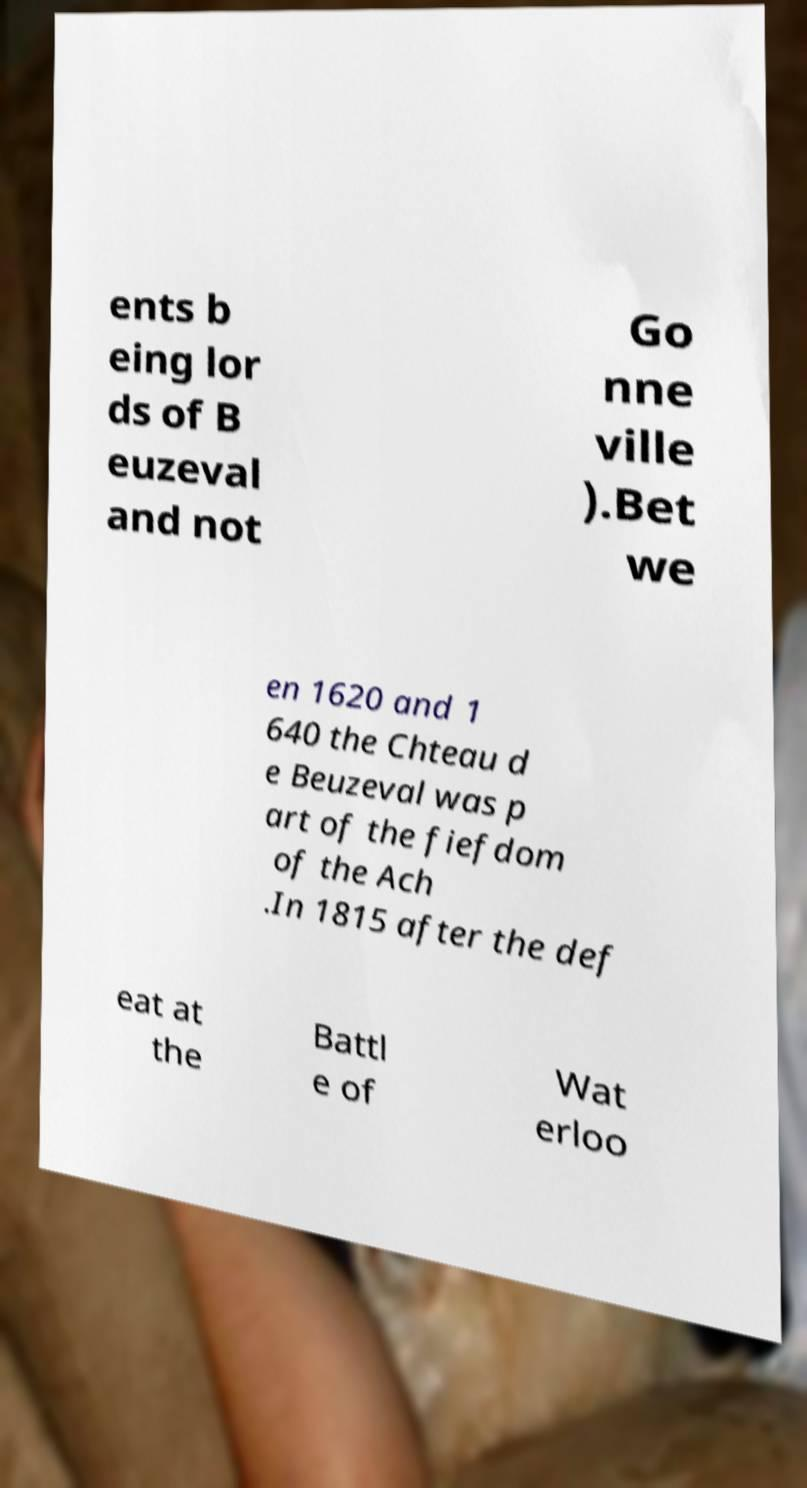Can you accurately transcribe the text from the provided image for me? ents b eing lor ds of B euzeval and not Go nne ville ).Bet we en 1620 and 1 640 the Chteau d e Beuzeval was p art of the fiefdom of the Ach .In 1815 after the def eat at the Battl e of Wat erloo 